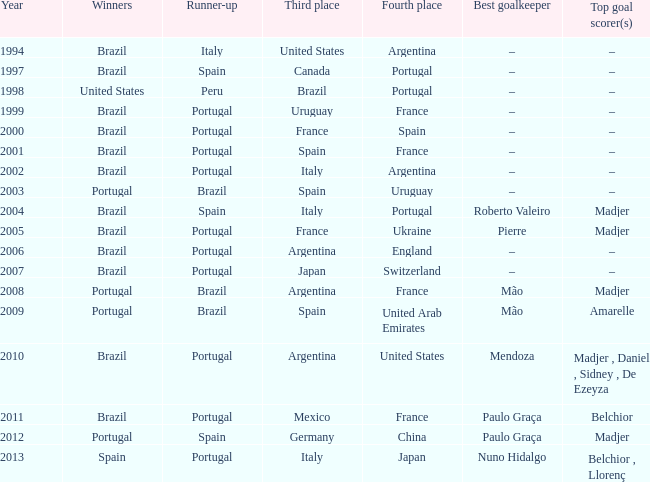What year was the runner-up Portugal with Italy in third place, and the gold keeper Nuno Hidalgo? 2013.0. 